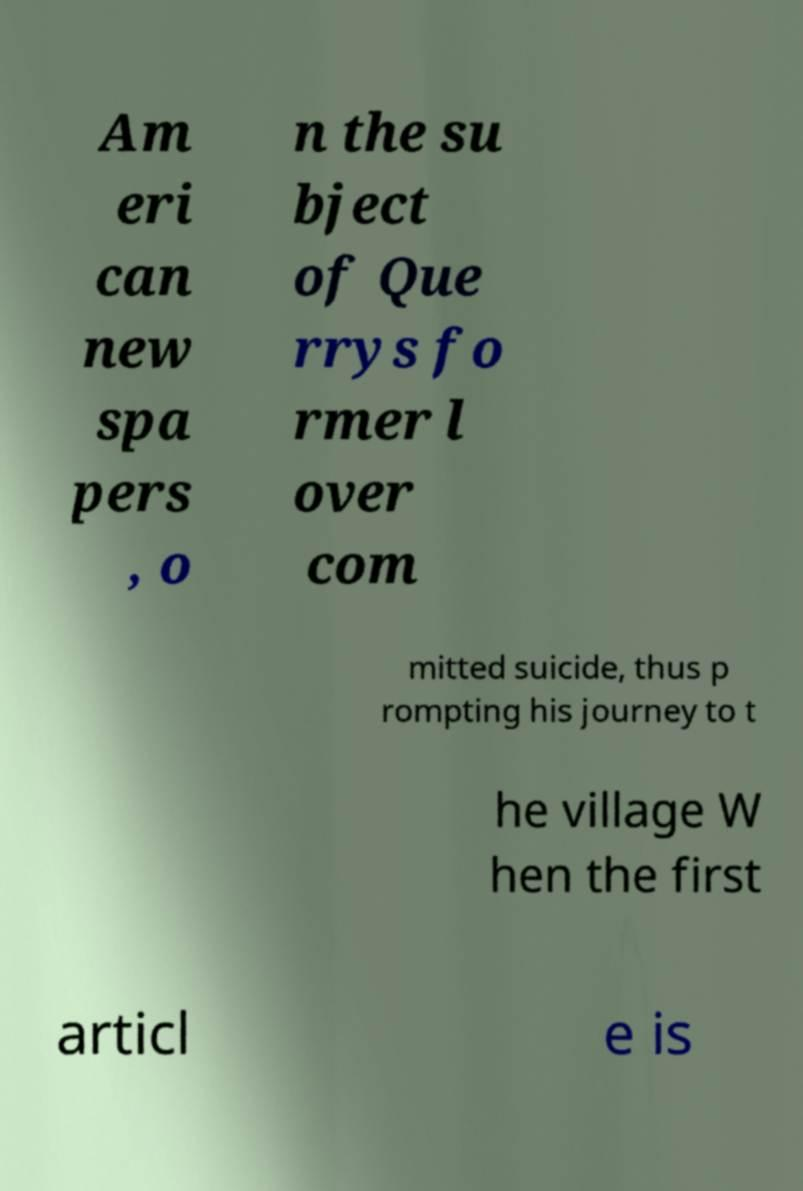Please identify and transcribe the text found in this image. Am eri can new spa pers , o n the su bject of Que rrys fo rmer l over com mitted suicide, thus p rompting his journey to t he village W hen the first articl e is 